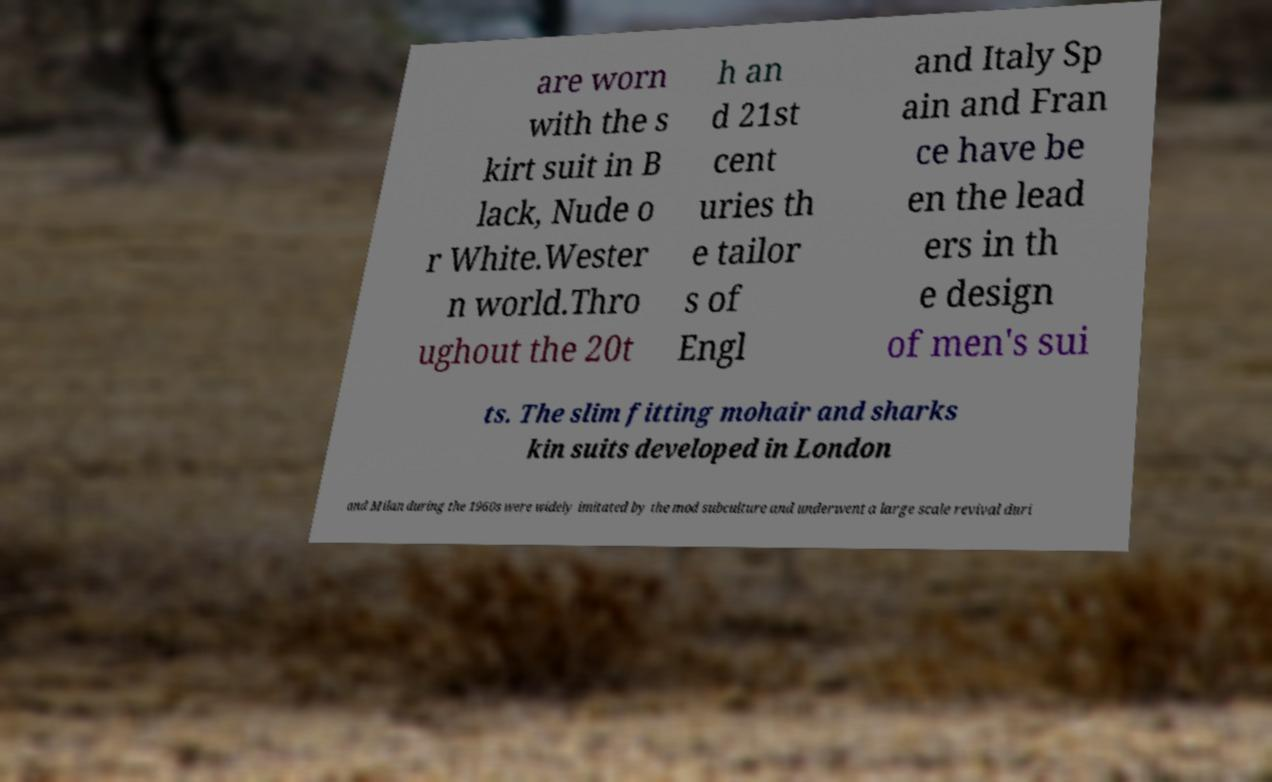Can you read and provide the text displayed in the image?This photo seems to have some interesting text. Can you extract and type it out for me? are worn with the s kirt suit in B lack, Nude o r White.Wester n world.Thro ughout the 20t h an d 21st cent uries th e tailor s of Engl and Italy Sp ain and Fran ce have be en the lead ers in th e design of men's sui ts. The slim fitting mohair and sharks kin suits developed in London and Milan during the 1960s were widely imitated by the mod subculture and underwent a large scale revival duri 